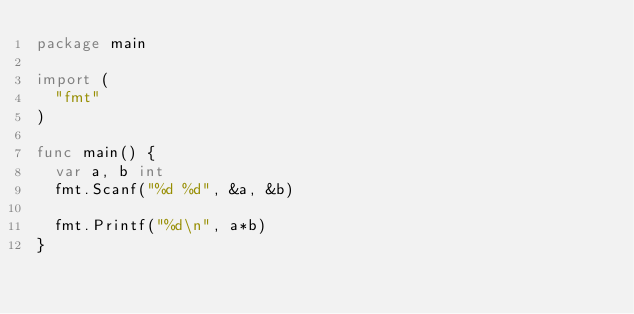Convert code to text. <code><loc_0><loc_0><loc_500><loc_500><_Go_>package main

import (
  "fmt"
)

func main() {
  var a, b int
  fmt.Scanf("%d %d", &a, &b)
  
  fmt.Printf("%d\n", a*b)
}</code> 